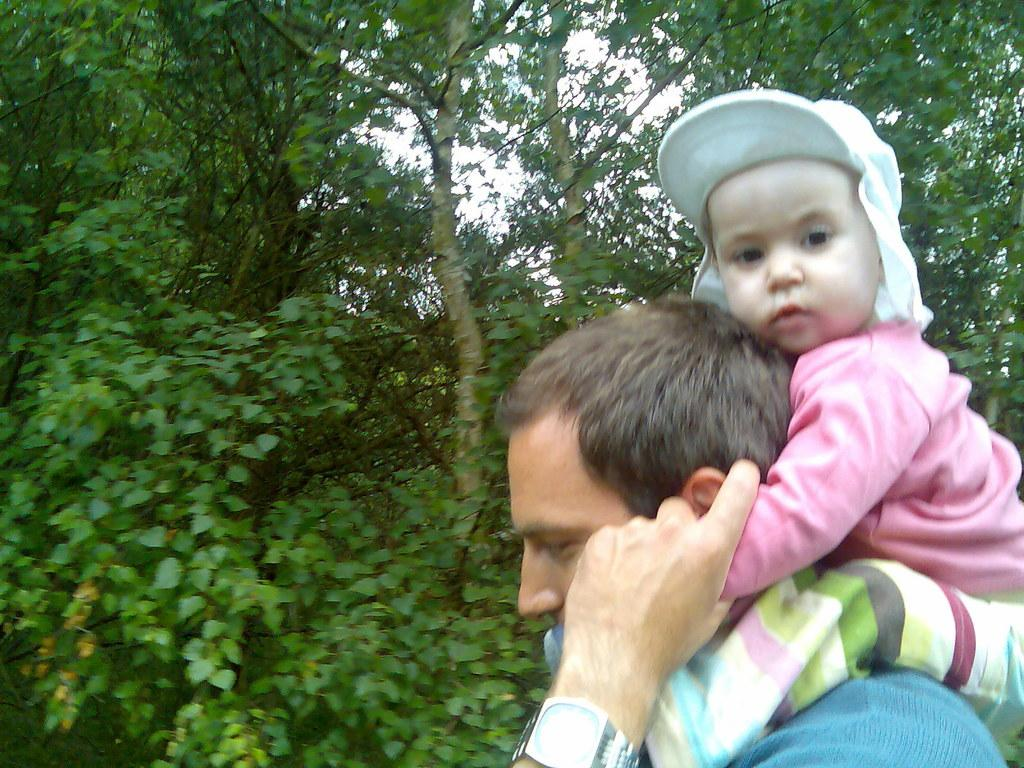Who is the main subject in the image? There is a man in the image. What is the man doing in the image? The man is holding a baby on his shoulders. What can be seen in the background of the image? There are trees in the background of the image. What type of fight is the man participating in with the baby in the image? There is no fight present in the image; the man is simply holding the baby on his shoulders. What hobbies does the man have, as seen in the image? The image does not provide information about the man's hobbies. 